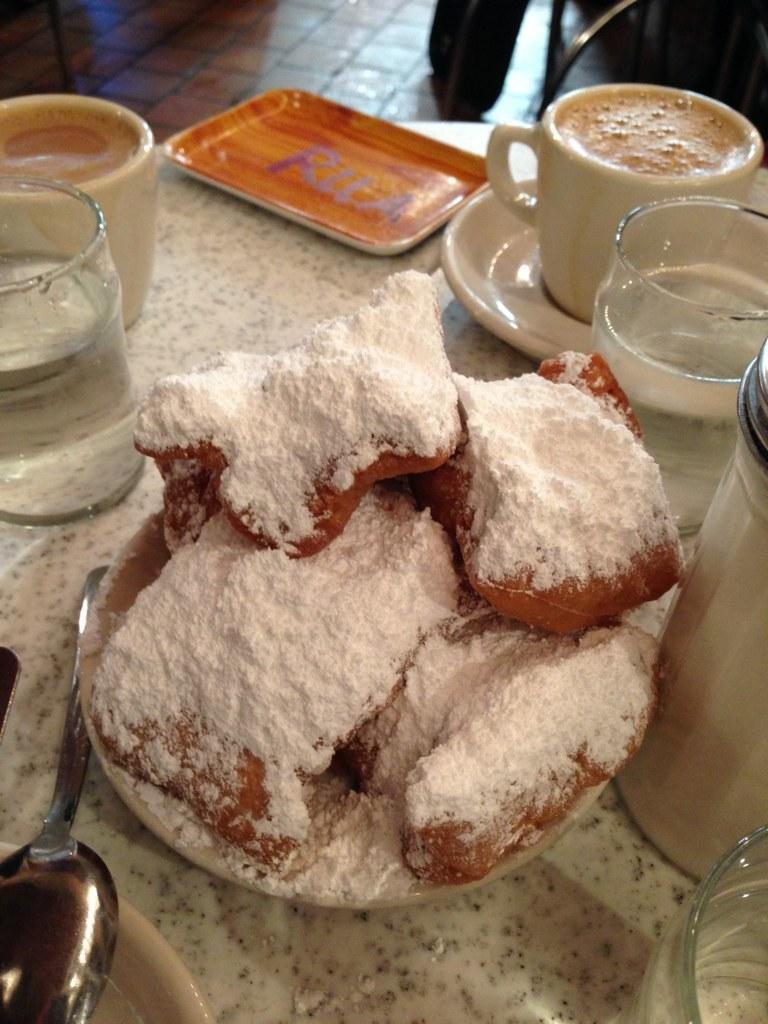Please provide a concise description of this image. In this image we can see the table, on the table there are plates, cups, saucer, bottle, spoon and some food items. At the back the object looks like a chair on the floor. 